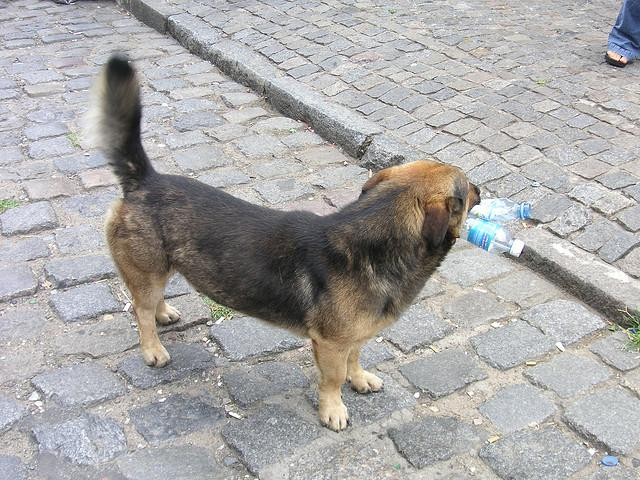What is in the dog's mouth? Please explain your reasoning. nothing. A dog has two clear bottles in its mouth. water bottles are often clear. 